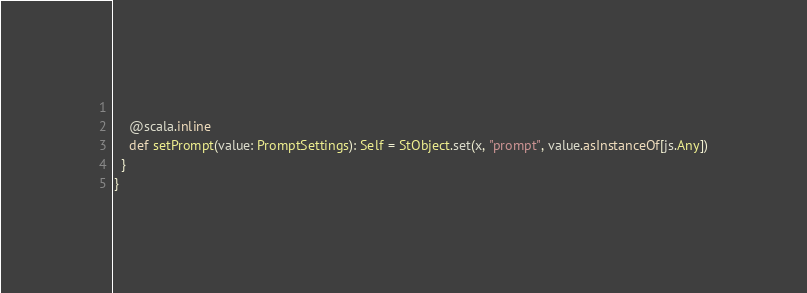<code> <loc_0><loc_0><loc_500><loc_500><_Scala_>    
    @scala.inline
    def setPrompt(value: PromptSettings): Self = StObject.set(x, "prompt", value.asInstanceOf[js.Any])
  }
}
</code> 